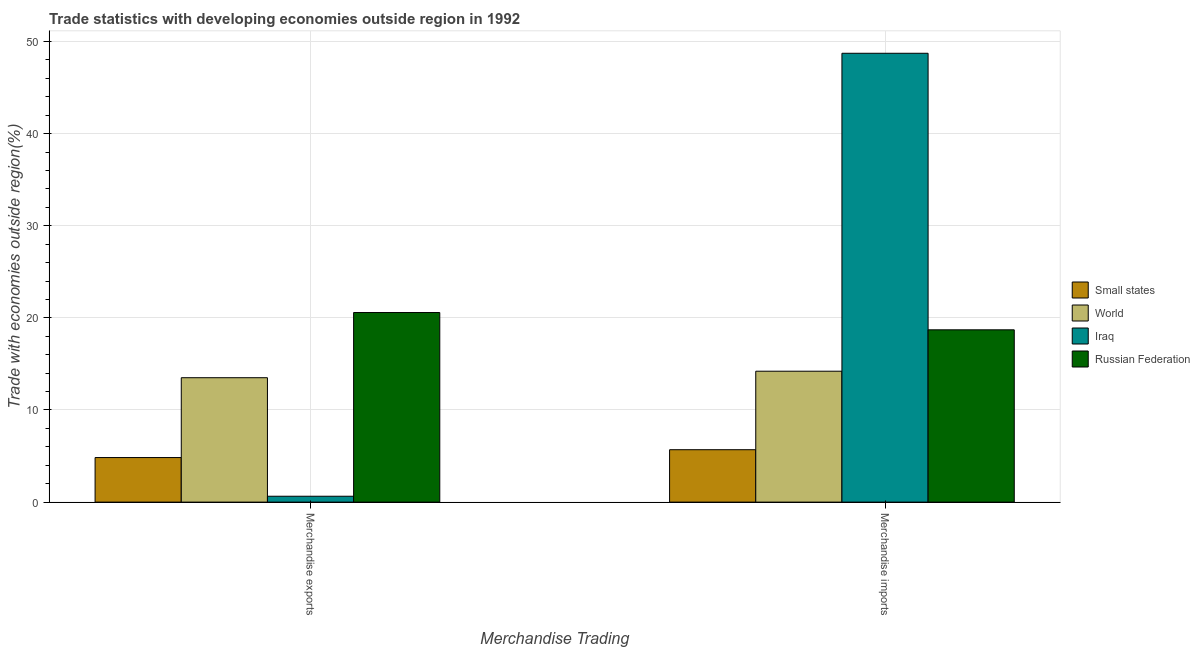How many different coloured bars are there?
Give a very brief answer. 4. How many groups of bars are there?
Make the answer very short. 2. How many bars are there on the 2nd tick from the left?
Provide a succinct answer. 4. How many bars are there on the 2nd tick from the right?
Offer a terse response. 4. What is the label of the 2nd group of bars from the left?
Provide a succinct answer. Merchandise imports. What is the merchandise exports in Iraq?
Your response must be concise. 0.64. Across all countries, what is the maximum merchandise imports?
Keep it short and to the point. 48.72. Across all countries, what is the minimum merchandise exports?
Provide a short and direct response. 0.64. In which country was the merchandise exports maximum?
Ensure brevity in your answer.  Russian Federation. In which country was the merchandise exports minimum?
Provide a short and direct response. Iraq. What is the total merchandise exports in the graph?
Provide a short and direct response. 39.56. What is the difference between the merchandise imports in Iraq and that in Russian Federation?
Your answer should be compact. 30.02. What is the difference between the merchandise exports in Iraq and the merchandise imports in World?
Your answer should be very brief. -13.57. What is the average merchandise exports per country?
Give a very brief answer. 9.89. What is the difference between the merchandise imports and merchandise exports in Iraq?
Keep it short and to the point. 48.08. What is the ratio of the merchandise exports in Iraq to that in Small states?
Provide a short and direct response. 0.13. In how many countries, is the merchandise imports greater than the average merchandise imports taken over all countries?
Offer a terse response. 1. What does the 1st bar from the left in Merchandise exports represents?
Give a very brief answer. Small states. How many bars are there?
Offer a very short reply. 8. Are all the bars in the graph horizontal?
Your answer should be very brief. No. How many countries are there in the graph?
Make the answer very short. 4. How are the legend labels stacked?
Your answer should be compact. Vertical. What is the title of the graph?
Offer a very short reply. Trade statistics with developing economies outside region in 1992. Does "Czech Republic" appear as one of the legend labels in the graph?
Keep it short and to the point. No. What is the label or title of the X-axis?
Your response must be concise. Merchandise Trading. What is the label or title of the Y-axis?
Your response must be concise. Trade with economies outside region(%). What is the Trade with economies outside region(%) of Small states in Merchandise exports?
Your answer should be very brief. 4.84. What is the Trade with economies outside region(%) in World in Merchandise exports?
Your answer should be very brief. 13.5. What is the Trade with economies outside region(%) of Iraq in Merchandise exports?
Provide a short and direct response. 0.64. What is the Trade with economies outside region(%) of Russian Federation in Merchandise exports?
Provide a short and direct response. 20.58. What is the Trade with economies outside region(%) in Small states in Merchandise imports?
Make the answer very short. 5.69. What is the Trade with economies outside region(%) in World in Merchandise imports?
Give a very brief answer. 14.21. What is the Trade with economies outside region(%) of Iraq in Merchandise imports?
Provide a succinct answer. 48.72. What is the Trade with economies outside region(%) in Russian Federation in Merchandise imports?
Offer a very short reply. 18.7. Across all Merchandise Trading, what is the maximum Trade with economies outside region(%) of Small states?
Provide a succinct answer. 5.69. Across all Merchandise Trading, what is the maximum Trade with economies outside region(%) of World?
Ensure brevity in your answer.  14.21. Across all Merchandise Trading, what is the maximum Trade with economies outside region(%) in Iraq?
Provide a short and direct response. 48.72. Across all Merchandise Trading, what is the maximum Trade with economies outside region(%) in Russian Federation?
Provide a succinct answer. 20.58. Across all Merchandise Trading, what is the minimum Trade with economies outside region(%) in Small states?
Provide a succinct answer. 4.84. Across all Merchandise Trading, what is the minimum Trade with economies outside region(%) in World?
Provide a succinct answer. 13.5. Across all Merchandise Trading, what is the minimum Trade with economies outside region(%) in Iraq?
Offer a very short reply. 0.64. Across all Merchandise Trading, what is the minimum Trade with economies outside region(%) in Russian Federation?
Ensure brevity in your answer.  18.7. What is the total Trade with economies outside region(%) of Small states in the graph?
Provide a succinct answer. 10.53. What is the total Trade with economies outside region(%) of World in the graph?
Offer a very short reply. 27.71. What is the total Trade with economies outside region(%) of Iraq in the graph?
Give a very brief answer. 49.36. What is the total Trade with economies outside region(%) of Russian Federation in the graph?
Your response must be concise. 39.28. What is the difference between the Trade with economies outside region(%) of Small states in Merchandise exports and that in Merchandise imports?
Your response must be concise. -0.85. What is the difference between the Trade with economies outside region(%) in World in Merchandise exports and that in Merchandise imports?
Your response must be concise. -0.71. What is the difference between the Trade with economies outside region(%) in Iraq in Merchandise exports and that in Merchandise imports?
Offer a very short reply. -48.08. What is the difference between the Trade with economies outside region(%) in Russian Federation in Merchandise exports and that in Merchandise imports?
Offer a terse response. 1.88. What is the difference between the Trade with economies outside region(%) of Small states in Merchandise exports and the Trade with economies outside region(%) of World in Merchandise imports?
Keep it short and to the point. -9.37. What is the difference between the Trade with economies outside region(%) of Small states in Merchandise exports and the Trade with economies outside region(%) of Iraq in Merchandise imports?
Keep it short and to the point. -43.88. What is the difference between the Trade with economies outside region(%) in Small states in Merchandise exports and the Trade with economies outside region(%) in Russian Federation in Merchandise imports?
Give a very brief answer. -13.87. What is the difference between the Trade with economies outside region(%) in World in Merchandise exports and the Trade with economies outside region(%) in Iraq in Merchandise imports?
Your answer should be very brief. -35.22. What is the difference between the Trade with economies outside region(%) of World in Merchandise exports and the Trade with economies outside region(%) of Russian Federation in Merchandise imports?
Provide a succinct answer. -5.2. What is the difference between the Trade with economies outside region(%) in Iraq in Merchandise exports and the Trade with economies outside region(%) in Russian Federation in Merchandise imports?
Provide a short and direct response. -18.06. What is the average Trade with economies outside region(%) in Small states per Merchandise Trading?
Provide a succinct answer. 5.26. What is the average Trade with economies outside region(%) in World per Merchandise Trading?
Ensure brevity in your answer.  13.86. What is the average Trade with economies outside region(%) of Iraq per Merchandise Trading?
Provide a succinct answer. 24.68. What is the average Trade with economies outside region(%) in Russian Federation per Merchandise Trading?
Make the answer very short. 19.64. What is the difference between the Trade with economies outside region(%) in Small states and Trade with economies outside region(%) in World in Merchandise exports?
Keep it short and to the point. -8.67. What is the difference between the Trade with economies outside region(%) of Small states and Trade with economies outside region(%) of Iraq in Merchandise exports?
Provide a short and direct response. 4.2. What is the difference between the Trade with economies outside region(%) of Small states and Trade with economies outside region(%) of Russian Federation in Merchandise exports?
Your answer should be compact. -15.74. What is the difference between the Trade with economies outside region(%) in World and Trade with economies outside region(%) in Iraq in Merchandise exports?
Ensure brevity in your answer.  12.87. What is the difference between the Trade with economies outside region(%) in World and Trade with economies outside region(%) in Russian Federation in Merchandise exports?
Provide a succinct answer. -7.08. What is the difference between the Trade with economies outside region(%) in Iraq and Trade with economies outside region(%) in Russian Federation in Merchandise exports?
Give a very brief answer. -19.94. What is the difference between the Trade with economies outside region(%) of Small states and Trade with economies outside region(%) of World in Merchandise imports?
Offer a very short reply. -8.52. What is the difference between the Trade with economies outside region(%) of Small states and Trade with economies outside region(%) of Iraq in Merchandise imports?
Offer a very short reply. -43.03. What is the difference between the Trade with economies outside region(%) of Small states and Trade with economies outside region(%) of Russian Federation in Merchandise imports?
Make the answer very short. -13.01. What is the difference between the Trade with economies outside region(%) in World and Trade with economies outside region(%) in Iraq in Merchandise imports?
Provide a succinct answer. -34.51. What is the difference between the Trade with economies outside region(%) of World and Trade with economies outside region(%) of Russian Federation in Merchandise imports?
Your answer should be compact. -4.49. What is the difference between the Trade with economies outside region(%) of Iraq and Trade with economies outside region(%) of Russian Federation in Merchandise imports?
Offer a very short reply. 30.02. What is the ratio of the Trade with economies outside region(%) of Small states in Merchandise exports to that in Merchandise imports?
Keep it short and to the point. 0.85. What is the ratio of the Trade with economies outside region(%) in World in Merchandise exports to that in Merchandise imports?
Provide a short and direct response. 0.95. What is the ratio of the Trade with economies outside region(%) of Iraq in Merchandise exports to that in Merchandise imports?
Your answer should be very brief. 0.01. What is the ratio of the Trade with economies outside region(%) of Russian Federation in Merchandise exports to that in Merchandise imports?
Provide a short and direct response. 1.1. What is the difference between the highest and the second highest Trade with economies outside region(%) in Small states?
Your response must be concise. 0.85. What is the difference between the highest and the second highest Trade with economies outside region(%) in World?
Your answer should be compact. 0.71. What is the difference between the highest and the second highest Trade with economies outside region(%) of Iraq?
Offer a terse response. 48.08. What is the difference between the highest and the second highest Trade with economies outside region(%) of Russian Federation?
Give a very brief answer. 1.88. What is the difference between the highest and the lowest Trade with economies outside region(%) of Small states?
Ensure brevity in your answer.  0.85. What is the difference between the highest and the lowest Trade with economies outside region(%) of World?
Give a very brief answer. 0.71. What is the difference between the highest and the lowest Trade with economies outside region(%) in Iraq?
Your answer should be very brief. 48.08. What is the difference between the highest and the lowest Trade with economies outside region(%) in Russian Federation?
Ensure brevity in your answer.  1.88. 